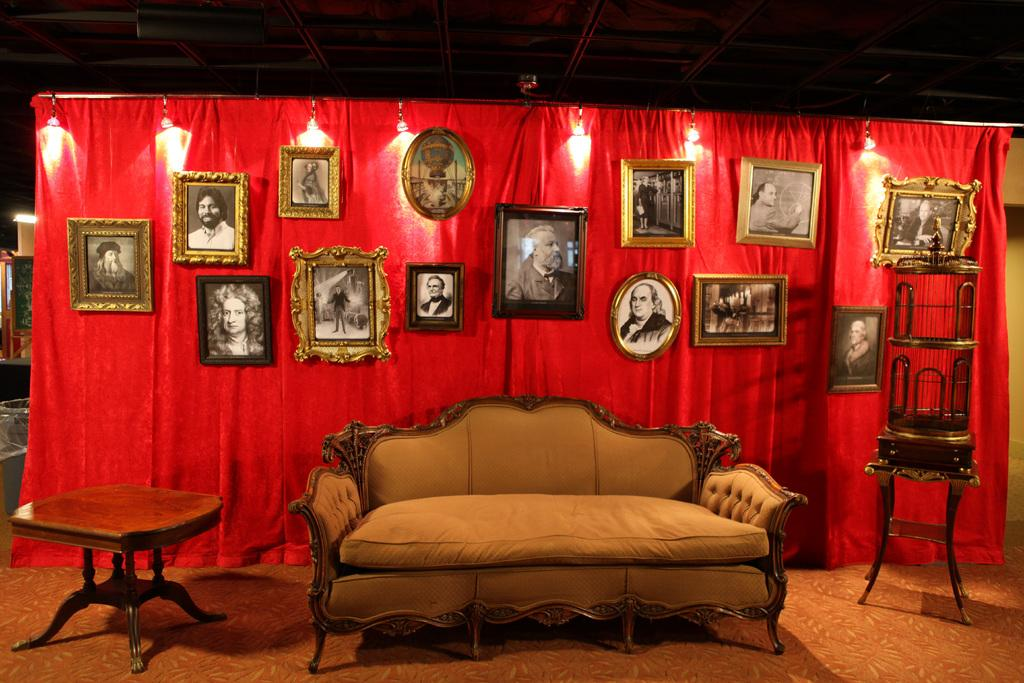What type of furniture is in the image? There is a sofa in the image. Is there any other furniture or objects near the sofa? Yes, there is a table beside the sofa. What can be seen hanging on the wall in the background? There are photo frames hanging on a red color screen in the background. What type of hole can be seen in the sofa in the image? There is no hole visible in the sofa in the image. 